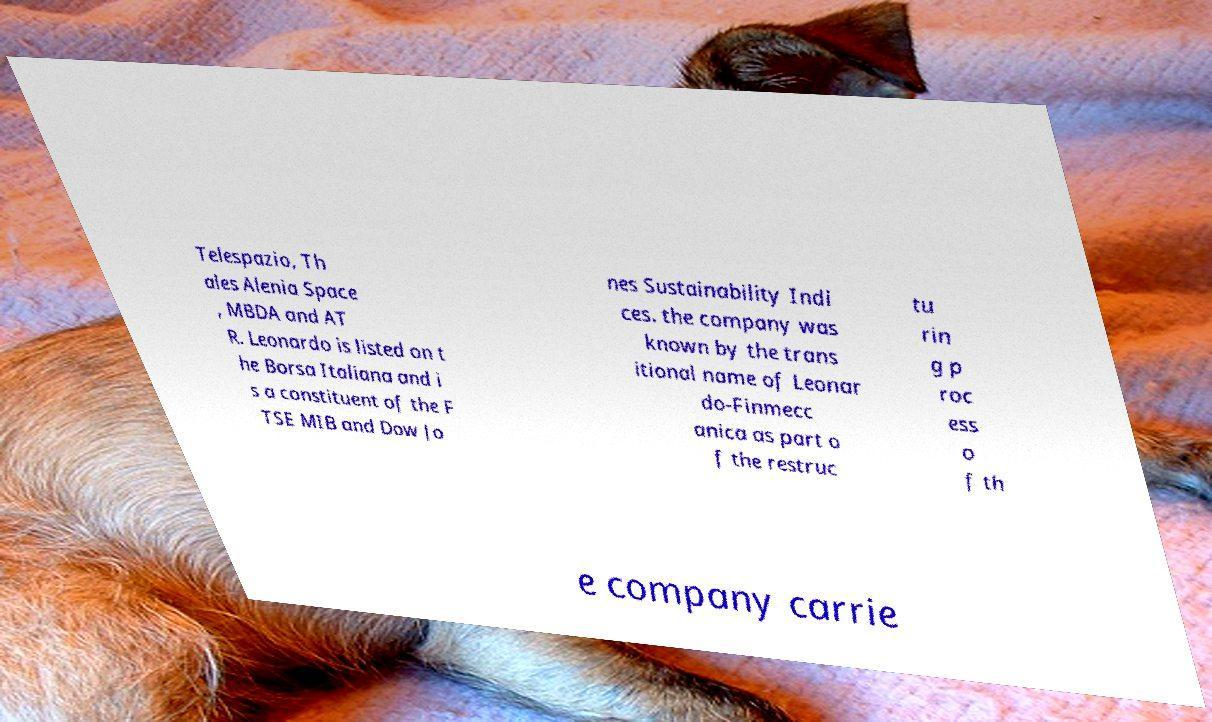There's text embedded in this image that I need extracted. Can you transcribe it verbatim? Telespazio, Th ales Alenia Space , MBDA and AT R. Leonardo is listed on t he Borsa Italiana and i s a constituent of the F TSE MIB and Dow Jo nes Sustainability Indi ces. the company was known by the trans itional name of Leonar do-Finmecc anica as part o f the restruc tu rin g p roc ess o f th e company carrie 